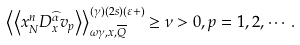Convert formula to latex. <formula><loc_0><loc_0><loc_500><loc_500>\left \langle \left \langle x _ { N } ^ { n } D _ { x } ^ { \widehat { \alpha } } v _ { p } \right \rangle \right \rangle _ { \omega \gamma , x , \overline { Q } } ^ { ( \gamma ) ( 2 s ) ( \varepsilon + ) } \geq \nu > 0 , p = 1 , 2 , \cdots .</formula> 